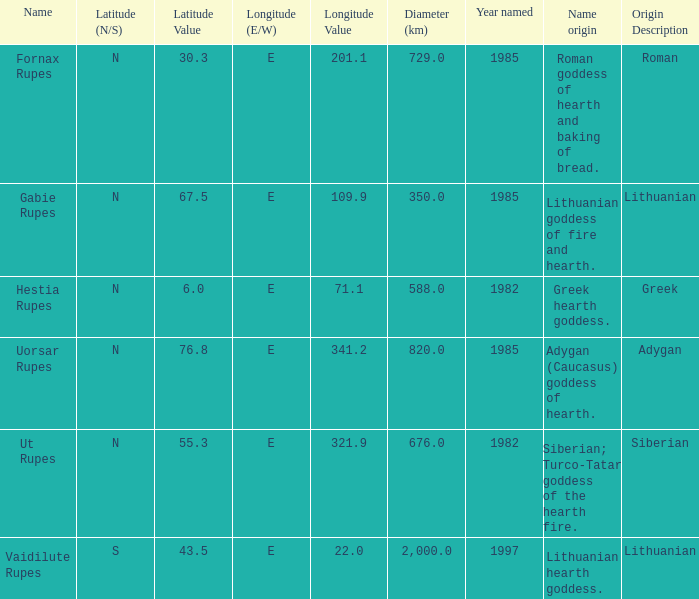At a longitude of 109.9e, how many features were found? 1.0. 